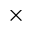<formula> <loc_0><loc_0><loc_500><loc_500>\times</formula> 